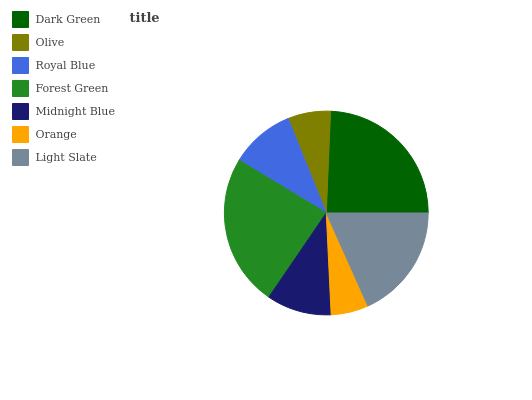Is Orange the minimum?
Answer yes or no. Yes. Is Dark Green the maximum?
Answer yes or no. Yes. Is Olive the minimum?
Answer yes or no. No. Is Olive the maximum?
Answer yes or no. No. Is Dark Green greater than Olive?
Answer yes or no. Yes. Is Olive less than Dark Green?
Answer yes or no. Yes. Is Olive greater than Dark Green?
Answer yes or no. No. Is Dark Green less than Olive?
Answer yes or no. No. Is Midnight Blue the high median?
Answer yes or no. Yes. Is Midnight Blue the low median?
Answer yes or no. Yes. Is Royal Blue the high median?
Answer yes or no. No. Is Dark Green the low median?
Answer yes or no. No. 